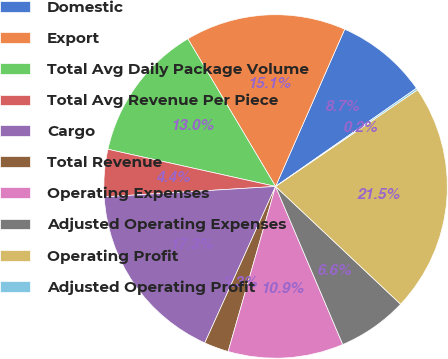Convert chart to OTSL. <chart><loc_0><loc_0><loc_500><loc_500><pie_chart><fcel>Domestic<fcel>Export<fcel>Total Avg Daily Package Volume<fcel>Total Avg Revenue Per Piece<fcel>Cargo<fcel>Total Revenue<fcel>Operating Expenses<fcel>Adjusted Operating Expenses<fcel>Operating Profit<fcel>Adjusted Operating Profit<nl><fcel>8.72%<fcel>15.13%<fcel>12.99%<fcel>4.44%<fcel>17.27%<fcel>2.31%<fcel>10.85%<fcel>6.58%<fcel>21.54%<fcel>0.17%<nl></chart> 